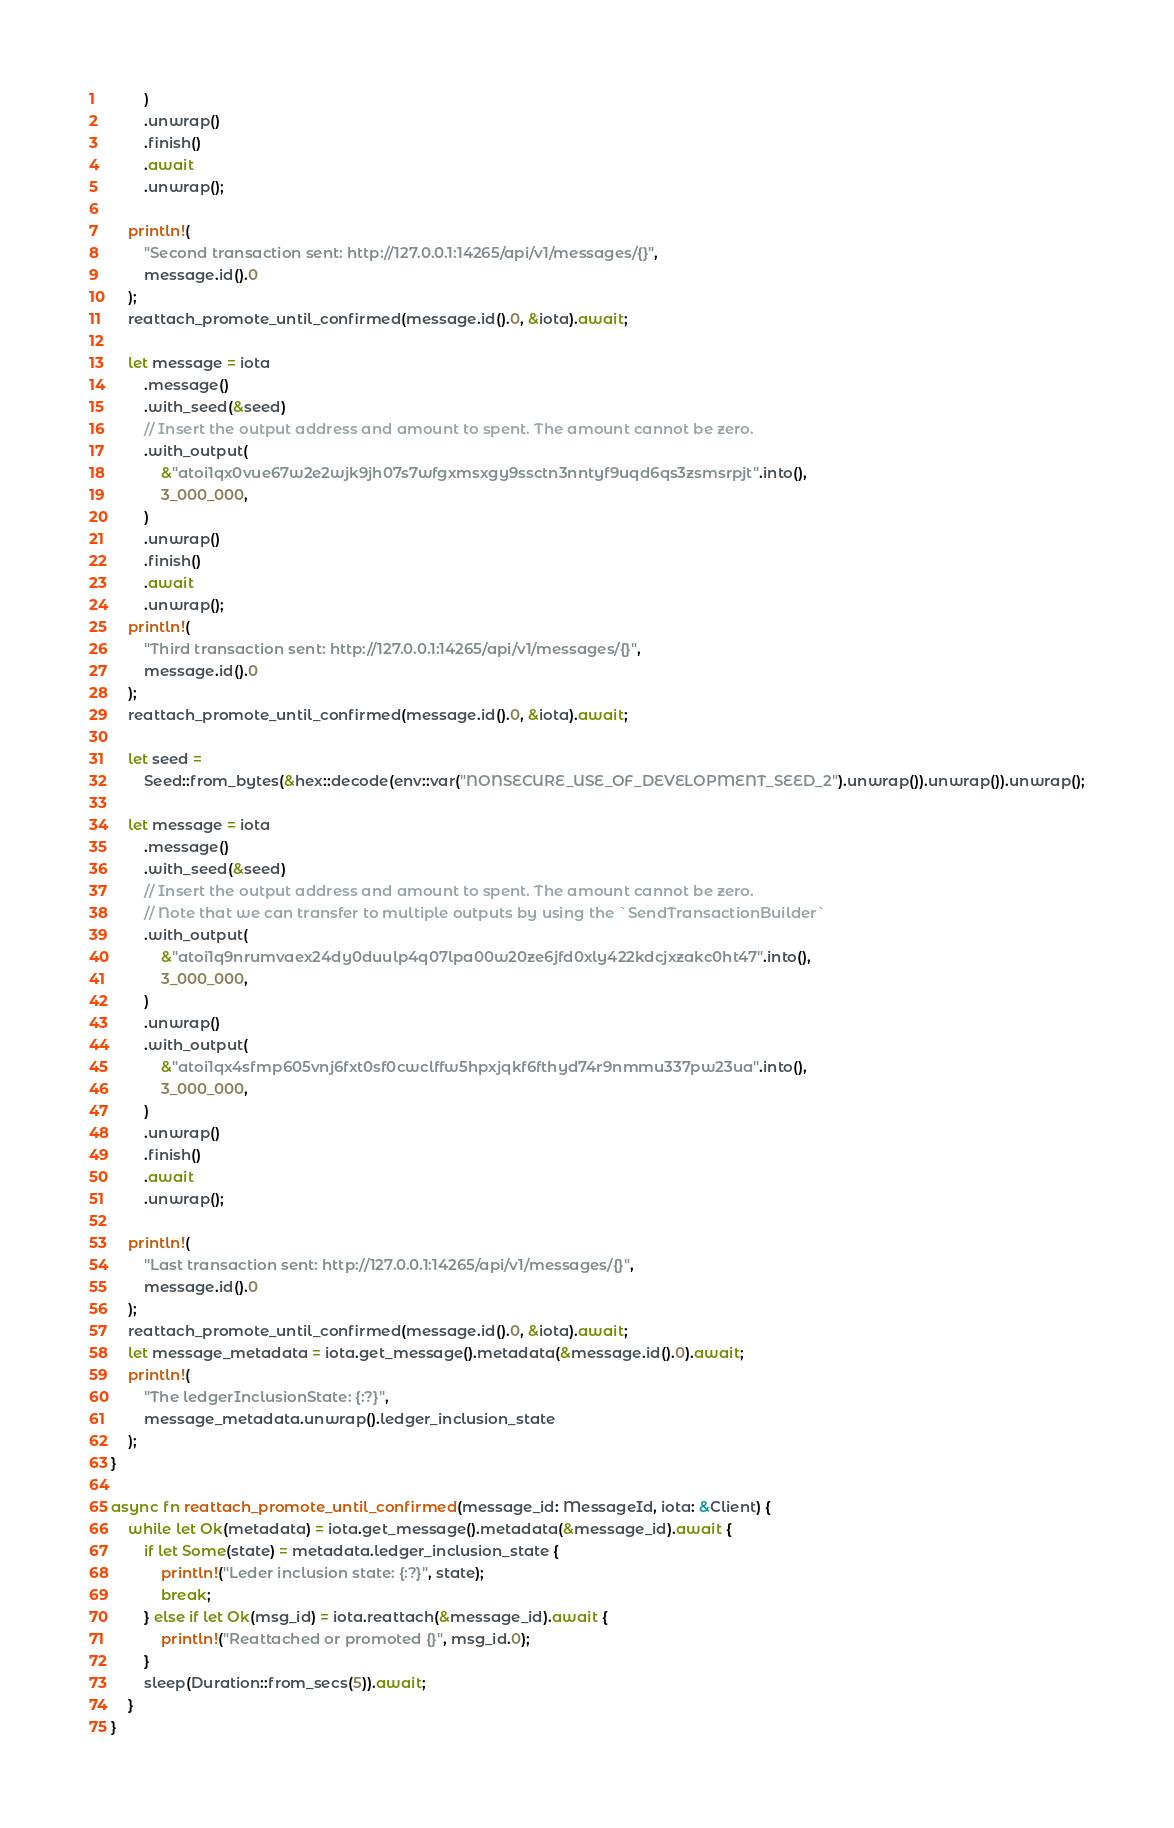<code> <loc_0><loc_0><loc_500><loc_500><_Rust_>        )
        .unwrap()
        .finish()
        .await
        .unwrap();

    println!(
        "Second transaction sent: http://127.0.0.1:14265/api/v1/messages/{}",
        message.id().0
    );
    reattach_promote_until_confirmed(message.id().0, &iota).await;

    let message = iota
        .message()
        .with_seed(&seed)
        // Insert the output address and amount to spent. The amount cannot be zero.
        .with_output(
            &"atoi1qx0vue67w2e2wjk9jh07s7wfgxmsxgy9ssctn3nntyf9uqd6qs3zsmsrpjt".into(),
            3_000_000,
        )
        .unwrap()
        .finish()
        .await
        .unwrap();
    println!(
        "Third transaction sent: http://127.0.0.1:14265/api/v1/messages/{}",
        message.id().0
    );
    reattach_promote_until_confirmed(message.id().0, &iota).await;

    let seed =
        Seed::from_bytes(&hex::decode(env::var("NONSECURE_USE_OF_DEVELOPMENT_SEED_2").unwrap()).unwrap()).unwrap();

    let message = iota
        .message()
        .with_seed(&seed)
        // Insert the output address and amount to spent. The amount cannot be zero.
        // Note that we can transfer to multiple outputs by using the `SendTransactionBuilder`
        .with_output(
            &"atoi1q9nrumvaex24dy0duulp4q07lpa00w20ze6jfd0xly422kdcjxzakc0ht47".into(),
            3_000_000,
        )
        .unwrap()
        .with_output(
            &"atoi1qx4sfmp605vnj6fxt0sf0cwclffw5hpxjqkf6fthyd74r9nmmu337pw23ua".into(),
            3_000_000,
        )
        .unwrap()
        .finish()
        .await
        .unwrap();

    println!(
        "Last transaction sent: http://127.0.0.1:14265/api/v1/messages/{}",
        message.id().0
    );
    reattach_promote_until_confirmed(message.id().0, &iota).await;
    let message_metadata = iota.get_message().metadata(&message.id().0).await;
    println!(
        "The ledgerInclusionState: {:?}",
        message_metadata.unwrap().ledger_inclusion_state
    );
}

async fn reattach_promote_until_confirmed(message_id: MessageId, iota: &Client) {
    while let Ok(metadata) = iota.get_message().metadata(&message_id).await {
        if let Some(state) = metadata.ledger_inclusion_state {
            println!("Leder inclusion state: {:?}", state);
            break;
        } else if let Ok(msg_id) = iota.reattach(&message_id).await {
            println!("Reattached or promoted {}", msg_id.0);
        }
        sleep(Duration::from_secs(5)).await;
    }
}
</code> 